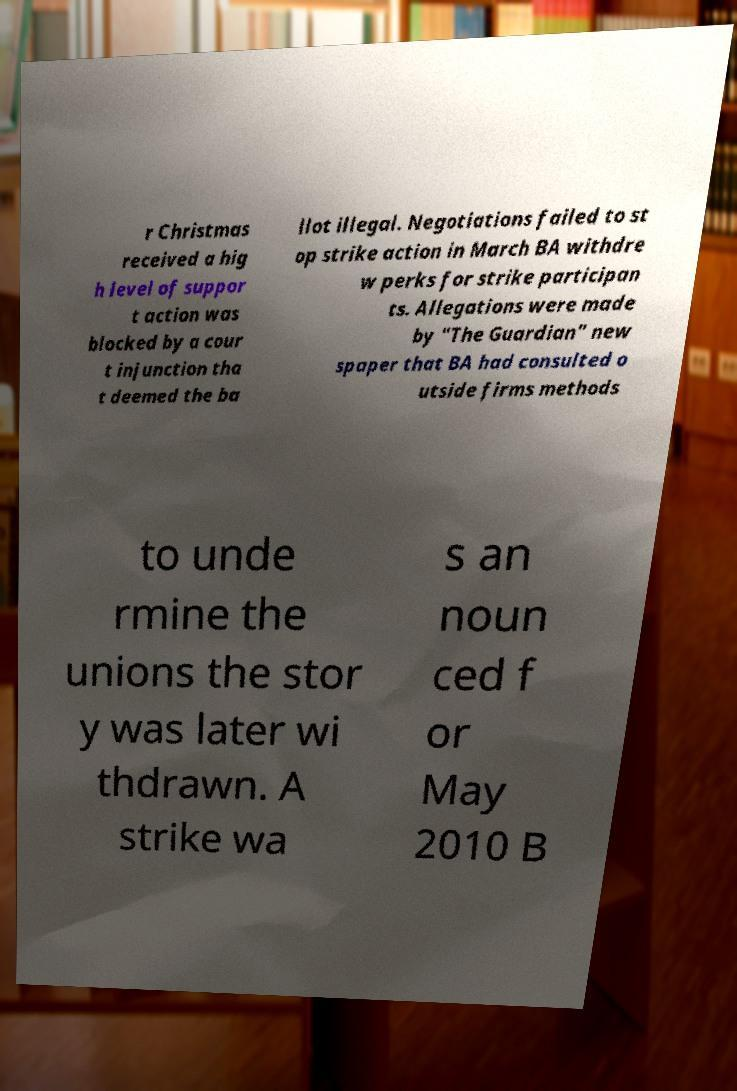What messages or text are displayed in this image? I need them in a readable, typed format. r Christmas received a hig h level of suppor t action was blocked by a cour t injunction tha t deemed the ba llot illegal. Negotiations failed to st op strike action in March BA withdre w perks for strike participan ts. Allegations were made by "The Guardian" new spaper that BA had consulted o utside firms methods to unde rmine the unions the stor y was later wi thdrawn. A strike wa s an noun ced f or May 2010 B 